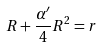Convert formula to latex. <formula><loc_0><loc_0><loc_500><loc_500>R + \frac { \alpha ^ { \prime } } { 4 } R ^ { 2 } = r</formula> 